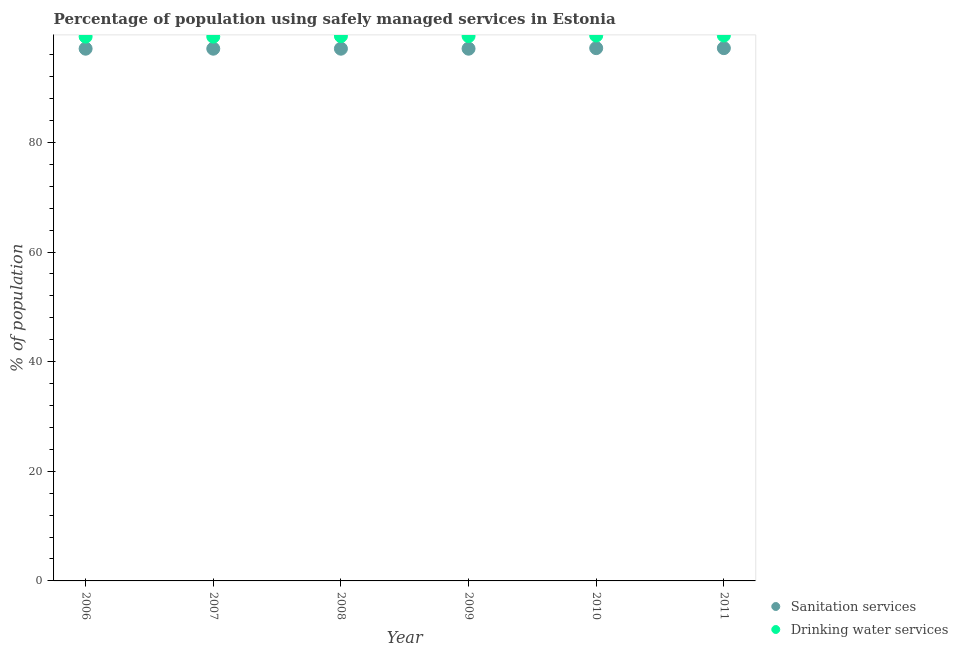How many different coloured dotlines are there?
Provide a succinct answer. 2. What is the percentage of population who used sanitation services in 2008?
Your response must be concise. 97.1. Across all years, what is the maximum percentage of population who used sanitation services?
Provide a short and direct response. 97.2. Across all years, what is the minimum percentage of population who used sanitation services?
Your answer should be compact. 97.1. In which year was the percentage of population who used drinking water services maximum?
Keep it short and to the point. 2010. What is the total percentage of population who used drinking water services in the graph?
Make the answer very short. 596.4. What is the difference between the percentage of population who used sanitation services in 2009 and that in 2010?
Your answer should be very brief. -0.1. What is the difference between the percentage of population who used drinking water services in 2011 and the percentage of population who used sanitation services in 2006?
Your answer should be very brief. 2.4. What is the average percentage of population who used drinking water services per year?
Offer a very short reply. 99.4. In the year 2007, what is the difference between the percentage of population who used sanitation services and percentage of population who used drinking water services?
Offer a very short reply. -2.2. What is the ratio of the percentage of population who used drinking water services in 2008 to that in 2009?
Your answer should be compact. 1. What is the difference between the highest and the lowest percentage of population who used drinking water services?
Your answer should be very brief. 0.2. In how many years, is the percentage of population who used drinking water services greater than the average percentage of population who used drinking water services taken over all years?
Provide a short and direct response. 4. Is the percentage of population who used drinking water services strictly less than the percentage of population who used sanitation services over the years?
Your answer should be compact. No. How many dotlines are there?
Ensure brevity in your answer.  2. How many years are there in the graph?
Provide a succinct answer. 6. What is the difference between two consecutive major ticks on the Y-axis?
Offer a terse response. 20. How many legend labels are there?
Keep it short and to the point. 2. How are the legend labels stacked?
Provide a short and direct response. Vertical. What is the title of the graph?
Offer a terse response. Percentage of population using safely managed services in Estonia. What is the label or title of the Y-axis?
Your answer should be compact. % of population. What is the % of population of Sanitation services in 2006?
Keep it short and to the point. 97.1. What is the % of population of Drinking water services in 2006?
Provide a succinct answer. 99.3. What is the % of population of Sanitation services in 2007?
Your response must be concise. 97.1. What is the % of population of Drinking water services in 2007?
Make the answer very short. 99.3. What is the % of population in Sanitation services in 2008?
Ensure brevity in your answer.  97.1. What is the % of population in Drinking water services in 2008?
Offer a very short reply. 99.4. What is the % of population of Sanitation services in 2009?
Your answer should be very brief. 97.1. What is the % of population in Drinking water services in 2009?
Provide a succinct answer. 99.4. What is the % of population in Sanitation services in 2010?
Keep it short and to the point. 97.2. What is the % of population of Drinking water services in 2010?
Offer a very short reply. 99.5. What is the % of population of Sanitation services in 2011?
Provide a succinct answer. 97.2. What is the % of population in Drinking water services in 2011?
Ensure brevity in your answer.  99.5. Across all years, what is the maximum % of population in Sanitation services?
Provide a succinct answer. 97.2. Across all years, what is the maximum % of population of Drinking water services?
Your response must be concise. 99.5. Across all years, what is the minimum % of population in Sanitation services?
Ensure brevity in your answer.  97.1. Across all years, what is the minimum % of population in Drinking water services?
Provide a short and direct response. 99.3. What is the total % of population in Sanitation services in the graph?
Keep it short and to the point. 582.8. What is the total % of population in Drinking water services in the graph?
Provide a short and direct response. 596.4. What is the difference between the % of population in Drinking water services in 2006 and that in 2007?
Offer a very short reply. 0. What is the difference between the % of population of Sanitation services in 2006 and that in 2008?
Ensure brevity in your answer.  0. What is the difference between the % of population of Sanitation services in 2006 and that in 2009?
Ensure brevity in your answer.  0. What is the difference between the % of population of Sanitation services in 2006 and that in 2011?
Offer a very short reply. -0.1. What is the difference between the % of population in Sanitation services in 2007 and that in 2009?
Your answer should be very brief. 0. What is the difference between the % of population in Sanitation services in 2007 and that in 2010?
Your response must be concise. -0.1. What is the difference between the % of population in Sanitation services in 2008 and that in 2009?
Offer a very short reply. 0. What is the difference between the % of population of Sanitation services in 2008 and that in 2010?
Provide a short and direct response. -0.1. What is the difference between the % of population in Drinking water services in 2008 and that in 2010?
Your answer should be very brief. -0.1. What is the difference between the % of population of Sanitation services in 2008 and that in 2011?
Offer a very short reply. -0.1. What is the difference between the % of population in Drinking water services in 2008 and that in 2011?
Make the answer very short. -0.1. What is the difference between the % of population in Sanitation services in 2009 and that in 2010?
Provide a succinct answer. -0.1. What is the difference between the % of population of Sanitation services in 2009 and that in 2011?
Your answer should be very brief. -0.1. What is the difference between the % of population of Sanitation services in 2010 and that in 2011?
Ensure brevity in your answer.  0. What is the difference between the % of population in Drinking water services in 2010 and that in 2011?
Give a very brief answer. 0. What is the difference between the % of population of Sanitation services in 2006 and the % of population of Drinking water services in 2009?
Your answer should be very brief. -2.3. What is the difference between the % of population of Sanitation services in 2006 and the % of population of Drinking water services in 2010?
Offer a very short reply. -2.4. What is the difference between the % of population in Sanitation services in 2006 and the % of population in Drinking water services in 2011?
Offer a terse response. -2.4. What is the difference between the % of population in Sanitation services in 2007 and the % of population in Drinking water services in 2008?
Your response must be concise. -2.3. What is the difference between the % of population of Sanitation services in 2007 and the % of population of Drinking water services in 2009?
Ensure brevity in your answer.  -2.3. What is the difference between the % of population in Sanitation services in 2008 and the % of population in Drinking water services in 2011?
Provide a succinct answer. -2.4. What is the difference between the % of population in Sanitation services in 2009 and the % of population in Drinking water services in 2011?
Give a very brief answer. -2.4. What is the difference between the % of population in Sanitation services in 2010 and the % of population in Drinking water services in 2011?
Your answer should be compact. -2.3. What is the average % of population of Sanitation services per year?
Provide a succinct answer. 97.13. What is the average % of population in Drinking water services per year?
Give a very brief answer. 99.4. In the year 2006, what is the difference between the % of population in Sanitation services and % of population in Drinking water services?
Keep it short and to the point. -2.2. In the year 2008, what is the difference between the % of population in Sanitation services and % of population in Drinking water services?
Make the answer very short. -2.3. In the year 2009, what is the difference between the % of population in Sanitation services and % of population in Drinking water services?
Your answer should be very brief. -2.3. In the year 2010, what is the difference between the % of population of Sanitation services and % of population of Drinking water services?
Provide a short and direct response. -2.3. What is the ratio of the % of population of Drinking water services in 2006 to that in 2007?
Provide a succinct answer. 1. What is the ratio of the % of population of Sanitation services in 2006 to that in 2009?
Provide a succinct answer. 1. What is the ratio of the % of population of Drinking water services in 2006 to that in 2009?
Offer a very short reply. 1. What is the ratio of the % of population in Drinking water services in 2007 to that in 2009?
Your response must be concise. 1. What is the ratio of the % of population in Sanitation services in 2007 to that in 2010?
Your response must be concise. 1. What is the ratio of the % of population of Drinking water services in 2007 to that in 2010?
Provide a short and direct response. 1. What is the ratio of the % of population of Sanitation services in 2007 to that in 2011?
Offer a very short reply. 1. What is the ratio of the % of population in Drinking water services in 2008 to that in 2009?
Your answer should be very brief. 1. What is the ratio of the % of population of Drinking water services in 2008 to that in 2010?
Your answer should be very brief. 1. What is the ratio of the % of population in Sanitation services in 2008 to that in 2011?
Keep it short and to the point. 1. What is the ratio of the % of population in Drinking water services in 2008 to that in 2011?
Offer a very short reply. 1. What is the ratio of the % of population of Sanitation services in 2009 to that in 2011?
Your response must be concise. 1. What is the ratio of the % of population in Sanitation services in 2010 to that in 2011?
Offer a terse response. 1. What is the ratio of the % of population in Drinking water services in 2010 to that in 2011?
Provide a succinct answer. 1. 